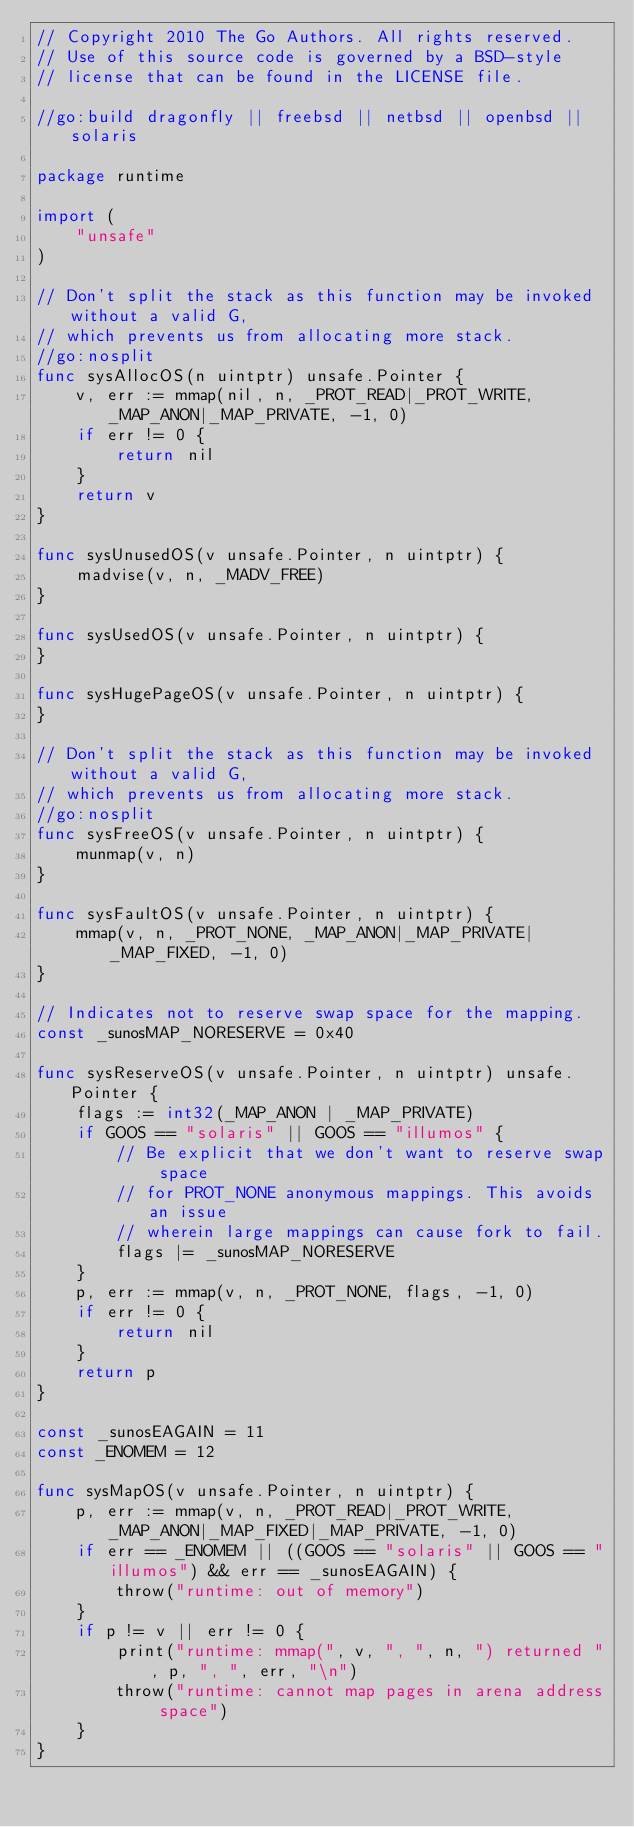Convert code to text. <code><loc_0><loc_0><loc_500><loc_500><_Go_>// Copyright 2010 The Go Authors. All rights reserved.
// Use of this source code is governed by a BSD-style
// license that can be found in the LICENSE file.

//go:build dragonfly || freebsd || netbsd || openbsd || solaris

package runtime

import (
	"unsafe"
)

// Don't split the stack as this function may be invoked without a valid G,
// which prevents us from allocating more stack.
//go:nosplit
func sysAllocOS(n uintptr) unsafe.Pointer {
	v, err := mmap(nil, n, _PROT_READ|_PROT_WRITE, _MAP_ANON|_MAP_PRIVATE, -1, 0)
	if err != 0 {
		return nil
	}
	return v
}

func sysUnusedOS(v unsafe.Pointer, n uintptr) {
	madvise(v, n, _MADV_FREE)
}

func sysUsedOS(v unsafe.Pointer, n uintptr) {
}

func sysHugePageOS(v unsafe.Pointer, n uintptr) {
}

// Don't split the stack as this function may be invoked without a valid G,
// which prevents us from allocating more stack.
//go:nosplit
func sysFreeOS(v unsafe.Pointer, n uintptr) {
	munmap(v, n)
}

func sysFaultOS(v unsafe.Pointer, n uintptr) {
	mmap(v, n, _PROT_NONE, _MAP_ANON|_MAP_PRIVATE|_MAP_FIXED, -1, 0)
}

// Indicates not to reserve swap space for the mapping.
const _sunosMAP_NORESERVE = 0x40

func sysReserveOS(v unsafe.Pointer, n uintptr) unsafe.Pointer {
	flags := int32(_MAP_ANON | _MAP_PRIVATE)
	if GOOS == "solaris" || GOOS == "illumos" {
		// Be explicit that we don't want to reserve swap space
		// for PROT_NONE anonymous mappings. This avoids an issue
		// wherein large mappings can cause fork to fail.
		flags |= _sunosMAP_NORESERVE
	}
	p, err := mmap(v, n, _PROT_NONE, flags, -1, 0)
	if err != 0 {
		return nil
	}
	return p
}

const _sunosEAGAIN = 11
const _ENOMEM = 12

func sysMapOS(v unsafe.Pointer, n uintptr) {
	p, err := mmap(v, n, _PROT_READ|_PROT_WRITE, _MAP_ANON|_MAP_FIXED|_MAP_PRIVATE, -1, 0)
	if err == _ENOMEM || ((GOOS == "solaris" || GOOS == "illumos") && err == _sunosEAGAIN) {
		throw("runtime: out of memory")
	}
	if p != v || err != 0 {
		print("runtime: mmap(", v, ", ", n, ") returned ", p, ", ", err, "\n")
		throw("runtime: cannot map pages in arena address space")
	}
}
</code> 